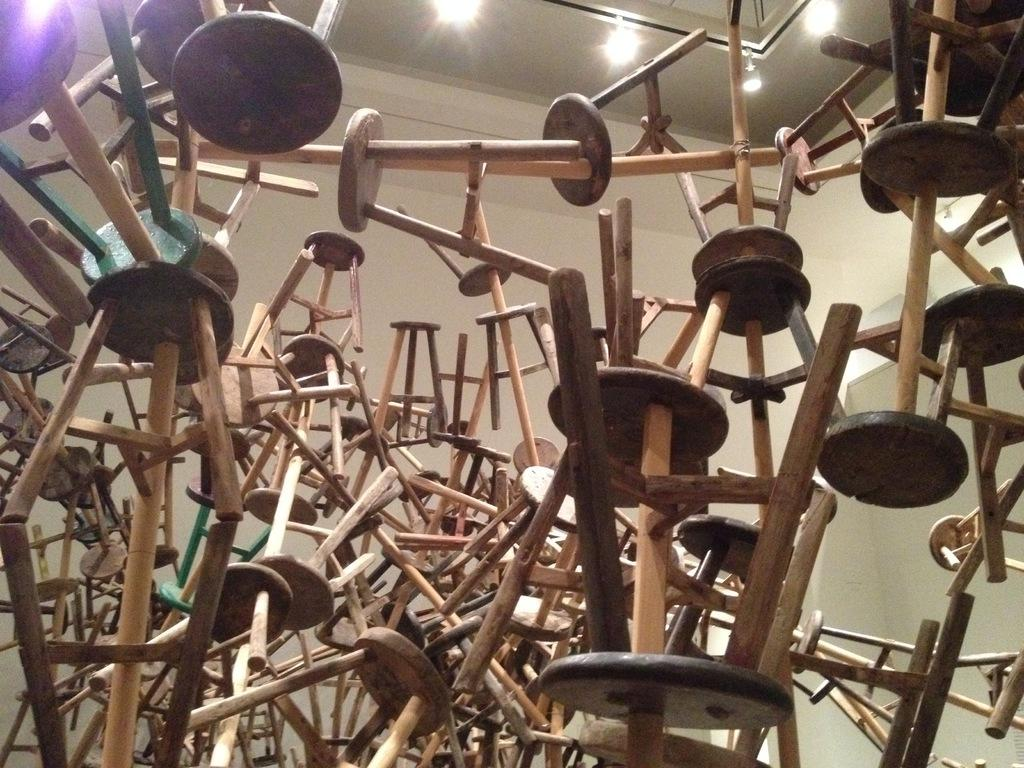What type of furniture is present in the image? There are wooden stools in the image. What can be seen behind the stools in the image? There is a wall in the background of the image. What is above the stools in the image? There is a ceiling with lights in the image. What mark can be seen on the journey depicted in the image? There is no journey or mark present in the image; it features wooden stools, a wall, and a ceiling with lights. 